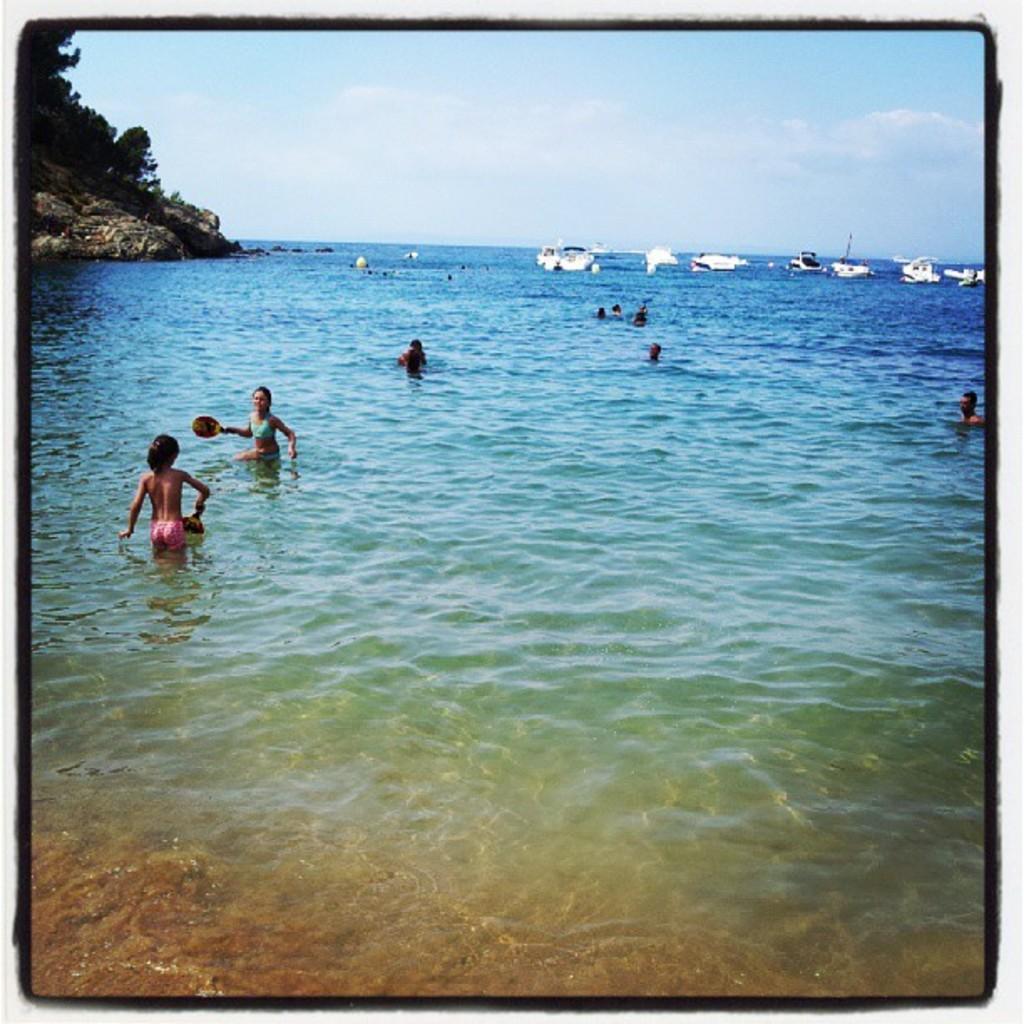Could you give a brief overview of what you see in this image? In the image there are people swimming in the beach and in the back there are many boats in the ocean with a hill on the left side and above its sky. 